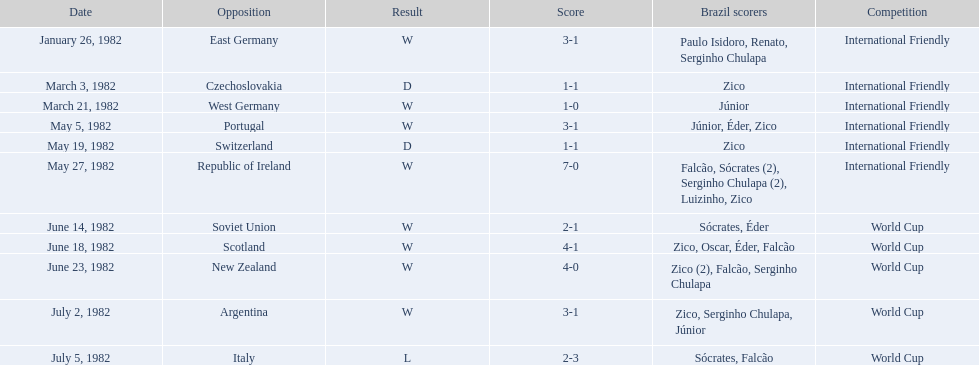What are the scheduled days? January 26, 1982, March 3, 1982, March 21, 1982, May 5, 1982, May 19, 1982, May 27, 1982, June 14, 1982, June 18, 1982, June 23, 1982, July 2, 1982, July 5, 1982. And which scheduled day is presented first? January 26, 1982. 